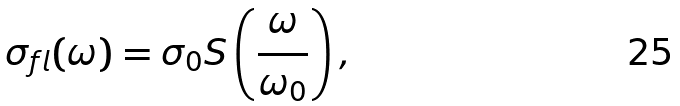Convert formula to latex. <formula><loc_0><loc_0><loc_500><loc_500>\sigma _ { f l } ( \omega ) = \sigma _ { 0 } S \left ( \frac { \omega } { \omega _ { 0 } } \right ) ,</formula> 